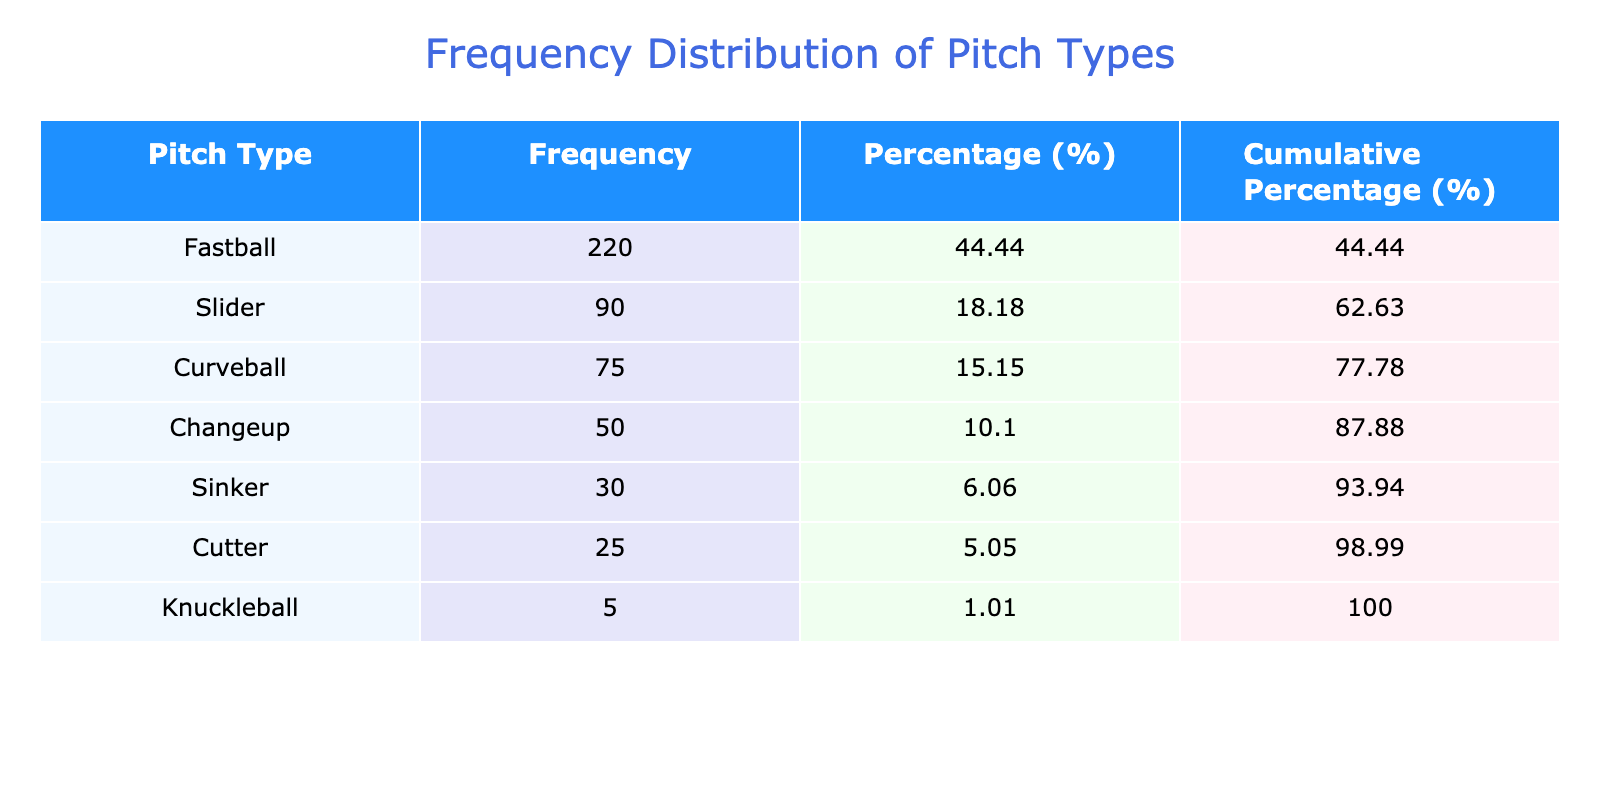What is the frequency of the Fastball pitch? The table shows the frequency of different pitch types, and the Fastball pitch has a frequency listed as 220.
Answer: 220 What percentage of the total pitches does the Changeup represent? The total frequency of all pitches is calculated by summing the frequencies: 220 + 90 + 75 + 50 + 30 + 25 + 5 = 490. The Changeup's frequency is 50. The percentage is (50 / 490) * 100, which is approximately 10.20.
Answer: 10.20 Is the frequency of Curveballs greater than that of Cutters? The frequency of Curveballs is 75, while the frequency of Cutters is 25. Since 75 is greater than 25, the statement is true.
Answer: Yes What is the cumulative percentage of the Sinker pitch? To find the cumulative percentage for the Sinker pitch, we need to sum the percentages of all pitches up to and including the Sinker. The frequencies are Fastball (220, 44.9%), Slider (90, 18.4%), Curveball (75, 15.3%), Changeup (50, 10.20%), Sinker (30, 6.1%). Adding these gives us: 44.9 + 18.4 + 15.3 + 10.20 + 6.1 = 94.9%. The cumulative percentage for the Sinker is thus 94.9%.
Answer: 94.9 What is the total frequency of pitches that are not Fastballs? To calculate the total frequency of pitches that are not Fastballs, we subtract the frequency of Fastballs (220) from the total frequency (490). Thus, 490 - 220 = 270.
Answer: 270 What is the average frequency of all pitch types? To find the average, we sum the frequencies of all pitch types (490) and divide by the number of pitch types (7). So, the average frequency is 490 / 7 = 70.
Answer: 70 Does the team throw more than twice as many Fastballs as Knuckleballs? The frequency of Fastballs is 220 and for Knuckleballs, it is 5. Twice the frequency of Knuckleballs is 2 * 5 = 10. Since 220 is greater than 10, the statement is true.
Answer: Yes What is the difference in frequency between the most thrown pitch and the least thrown pitch? The most thrown pitch is the Fastball with a frequency of 220, and the least thrown pitch is the Knuckleball with a frequency of 5. The difference is calculated as 220 - 5 = 215.
Answer: 215 What percentage of pitches are either a Sinker or a Cutter? The frequencies of Sinker and Cutter are 30 and 25, respectively. Their combined frequency is 30 + 25 = 55. The total frequency is 490 pitches, so the percentage is (55 / 490) * 100, which is approximately 11.22.
Answer: 11.22 